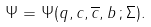<formula> <loc_0><loc_0><loc_500><loc_500>\Psi = \Psi ( q , c , \overline { c } , b \, ; \Sigma ) .</formula> 